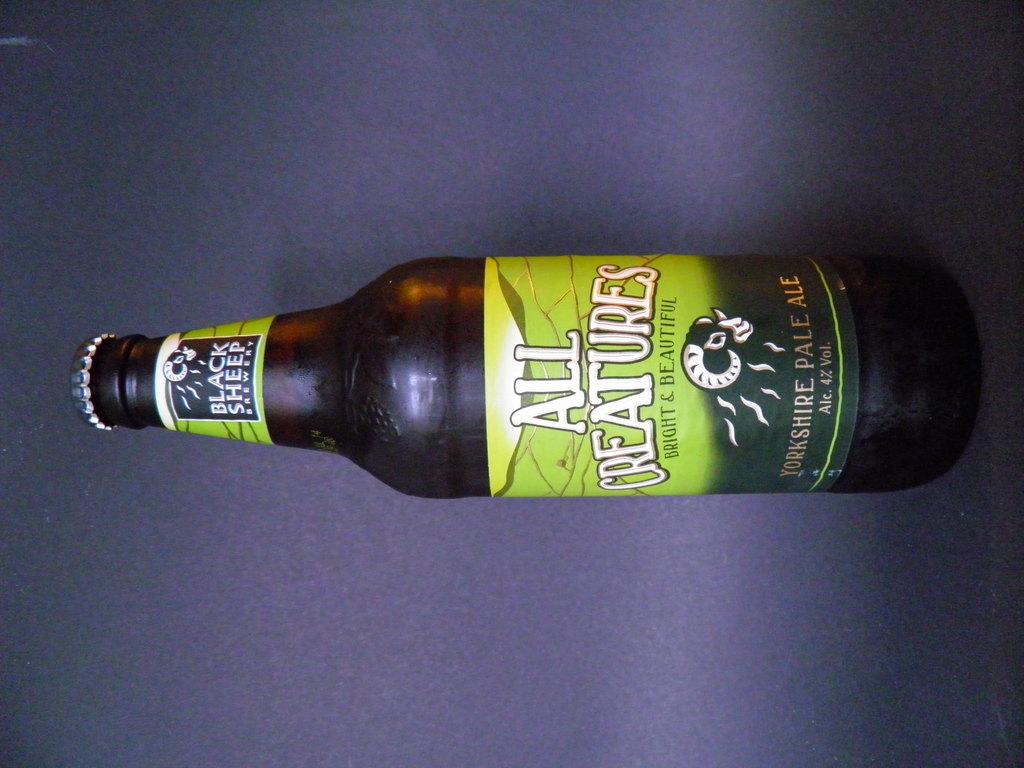What is the name of the brewery?
Your answer should be very brief. Black sheep. What is the volume of this bottle?
Ensure brevity in your answer.  4%. 